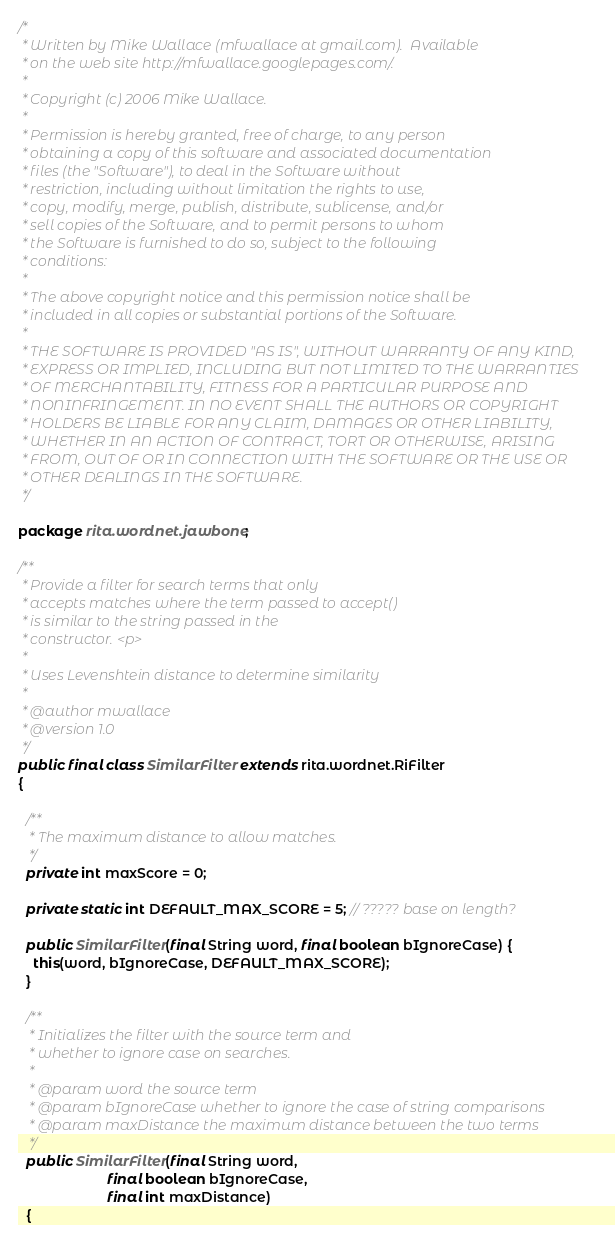<code> <loc_0><loc_0><loc_500><loc_500><_Java_>/*
 * Written by Mike Wallace (mfwallace at gmail.com).  Available
 * on the web site http://mfwallace.googlepages.com/.
 * 
 * Copyright (c) 2006 Mike Wallace.
 * 
 * Permission is hereby granted, free of charge, to any person
 * obtaining a copy of this software and associated documentation
 * files (the "Software"), to deal in the Software without
 * restriction, including without limitation the rights to use,
 * copy, modify, merge, publish, distribute, sublicense, and/or
 * sell copies of the Software, and to permit persons to whom
 * the Software is furnished to do so, subject to the following
 * conditions:
 * 
 * The above copyright notice and this permission notice shall be
 * included in all copies or substantial portions of the Software.
 * 
 * THE SOFTWARE IS PROVIDED "AS IS", WITHOUT WARRANTY OF ANY KIND,
 * EXPRESS OR IMPLIED, INCLUDING BUT NOT LIMITED TO THE WARRANTIES
 * OF MERCHANTABILITY, FITNESS FOR A PARTICULAR PURPOSE AND
 * NONINFRINGEMENT. IN NO EVENT SHALL THE AUTHORS OR COPYRIGHT
 * HOLDERS BE LIABLE FOR ANY CLAIM, DAMAGES OR OTHER LIABILITY,
 * WHETHER IN AN ACTION OF CONTRACT, TORT OR OTHERWISE, ARISING
 * FROM, OUT OF OR IN CONNECTION WITH THE SOFTWARE OR THE USE OR
 * OTHER DEALINGS IN THE SOFTWARE.
 */

package rita.wordnet.jawbone;

/**
 * Provide a filter for search terms that only
 * accepts matches where the term passed to accept()
 * is similar to the string passed in the
 * constructor. <p>
 * 
 * Uses Levenshtein distance to determine similarity
 * 
 * @author mwallace
 * @version 1.0
 */
public final class SimilarFilter extends rita.wordnet.RiFilter
{

  /**
   * The maximum distance to allow matches.
   */
  private int maxScore = 0;
  
  private static int DEFAULT_MAX_SCORE = 5; // ????? base on length?
  
  public SimilarFilter(final String word, final boolean bIgnoreCase) {
    this(word, bIgnoreCase, DEFAULT_MAX_SCORE);
  }
  
  /**
   * Initializes the filter with the source term and
   * whether to ignore case on searches.
   * 
   * @param word the source term
   * @param bIgnoreCase whether to ignore the case of string comparisons
   * @param maxDistance the maximum distance between the two terms
   */
  public SimilarFilter(final String word,
                       final boolean bIgnoreCase,
                       final int maxDistance)
  {</code> 